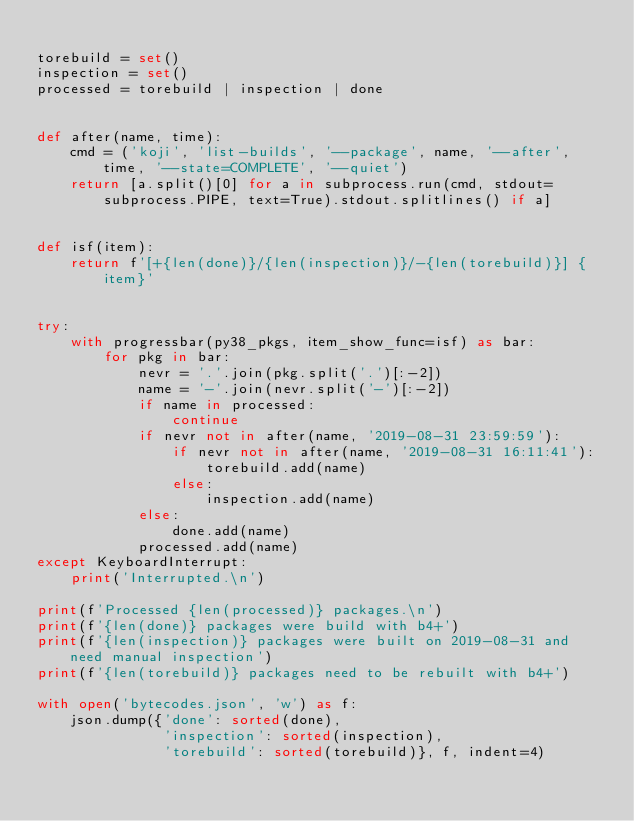<code> <loc_0><loc_0><loc_500><loc_500><_Python_>
torebuild = set()
inspection = set()
processed = torebuild | inspection | done


def after(name, time):
    cmd = ('koji', 'list-builds', '--package', name, '--after', time, '--state=COMPLETE', '--quiet')
    return [a.split()[0] for a in subprocess.run(cmd, stdout=subprocess.PIPE, text=True).stdout.splitlines() if a]


def isf(item):
    return f'[+{len(done)}/{len(inspection)}/-{len(torebuild)}] {item}'


try:
    with progressbar(py38_pkgs, item_show_func=isf) as bar:
        for pkg in bar:
            nevr = '.'.join(pkg.split('.')[:-2])
            name = '-'.join(nevr.split('-')[:-2])
            if name in processed:
                continue
            if nevr not in after(name, '2019-08-31 23:59:59'):
                if nevr not in after(name, '2019-08-31 16:11:41'):
                    torebuild.add(name)
                else:
                    inspection.add(name)
            else:
                done.add(name)
            processed.add(name)
except KeyboardInterrupt:
    print('Interrupted.\n')

print(f'Processed {len(processed)} packages.\n')
print(f'{len(done)} packages were build with b4+')
print(f'{len(inspection)} packages were built on 2019-08-31 and need manual inspection')
print(f'{len(torebuild)} packages need to be rebuilt with b4+')

with open('bytecodes.json', 'w') as f:
    json.dump({'done': sorted(done),
               'inspection': sorted(inspection),
               'torebuild': sorted(torebuild)}, f, indent=4)
</code> 